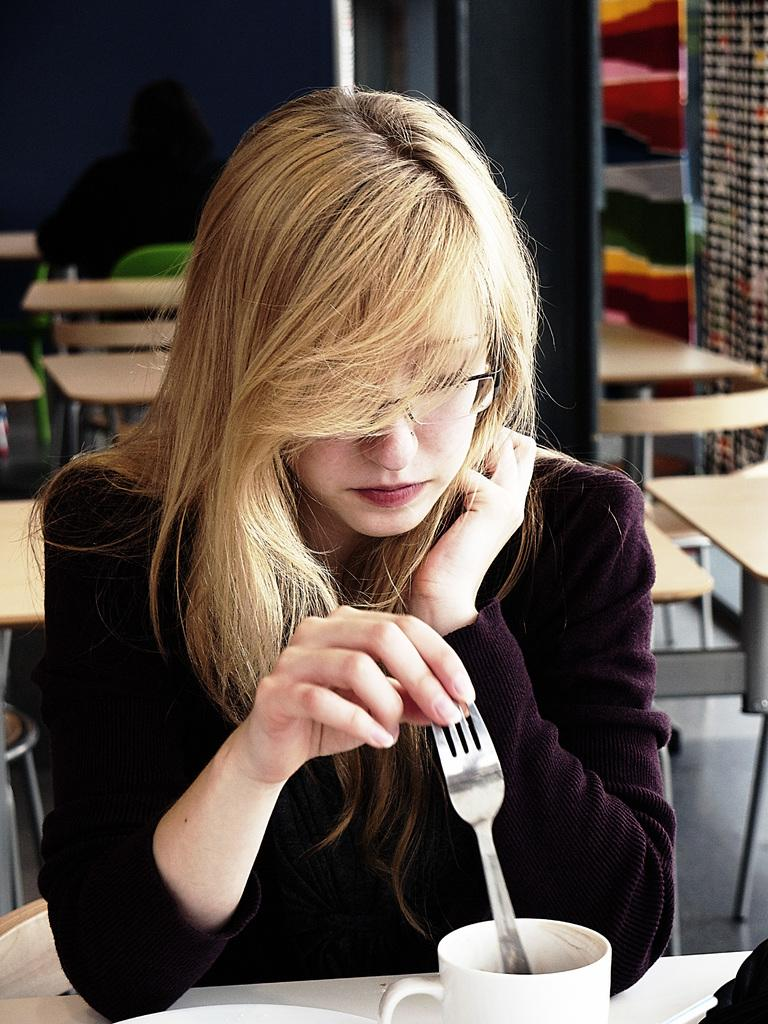Who is present in the image? There is a woman in the image. What is the woman doing in the image? The woman is sitting in the image. What is the woman holding in the image? The woman is holding a spoon in the image. What is in front of the woman in the image? There is a cup in front of the woman in the image. What can be seen in the background of the image? There is a wall and a pole in the background of the image. How many bees can be seen joining the woman in the image? There are no bees present in the image, and therefore no bees can be seen joining the woman. 